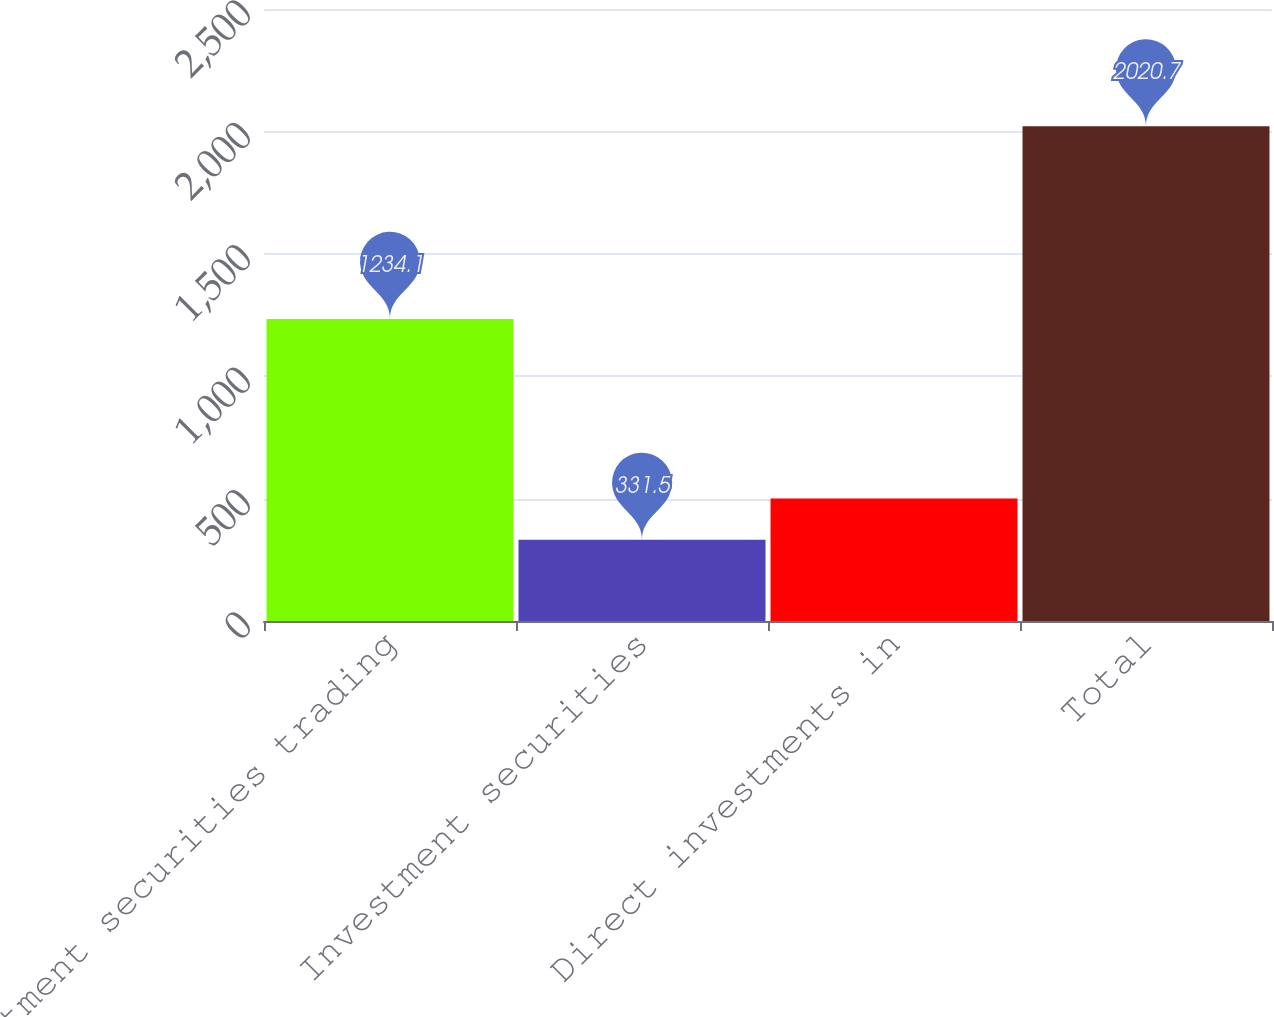Convert chart. <chart><loc_0><loc_0><loc_500><loc_500><bar_chart><fcel>Investment securities trading<fcel>Investment securities<fcel>Direct investments in<fcel>Total<nl><fcel>1234.1<fcel>331.5<fcel>500.42<fcel>2020.7<nl></chart> 